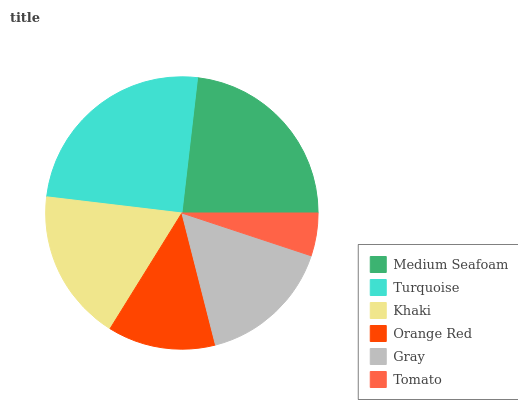Is Tomato the minimum?
Answer yes or no. Yes. Is Turquoise the maximum?
Answer yes or no. Yes. Is Khaki the minimum?
Answer yes or no. No. Is Khaki the maximum?
Answer yes or no. No. Is Turquoise greater than Khaki?
Answer yes or no. Yes. Is Khaki less than Turquoise?
Answer yes or no. Yes. Is Khaki greater than Turquoise?
Answer yes or no. No. Is Turquoise less than Khaki?
Answer yes or no. No. Is Khaki the high median?
Answer yes or no. Yes. Is Gray the low median?
Answer yes or no. Yes. Is Turquoise the high median?
Answer yes or no. No. Is Medium Seafoam the low median?
Answer yes or no. No. 